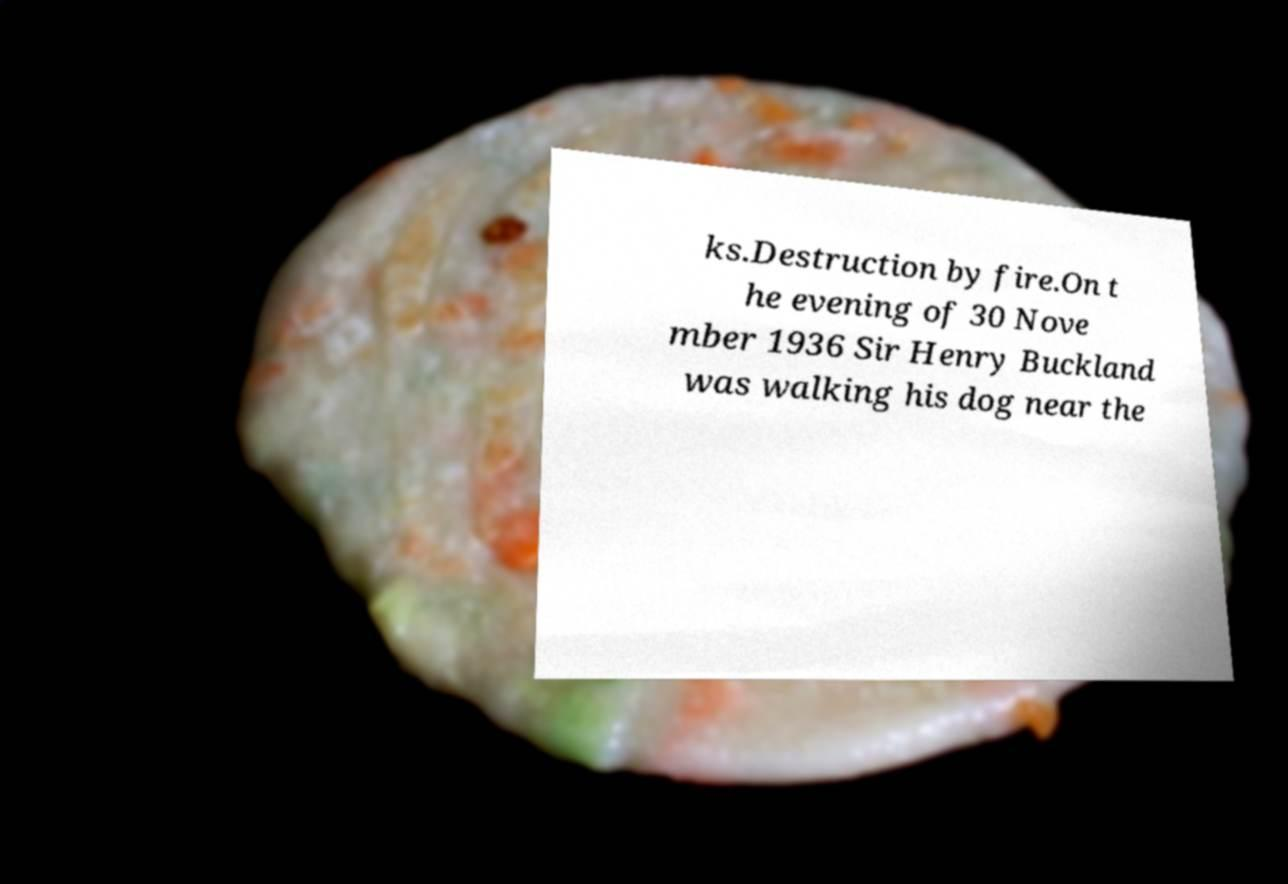Please identify and transcribe the text found in this image. ks.Destruction by fire.On t he evening of 30 Nove mber 1936 Sir Henry Buckland was walking his dog near the 